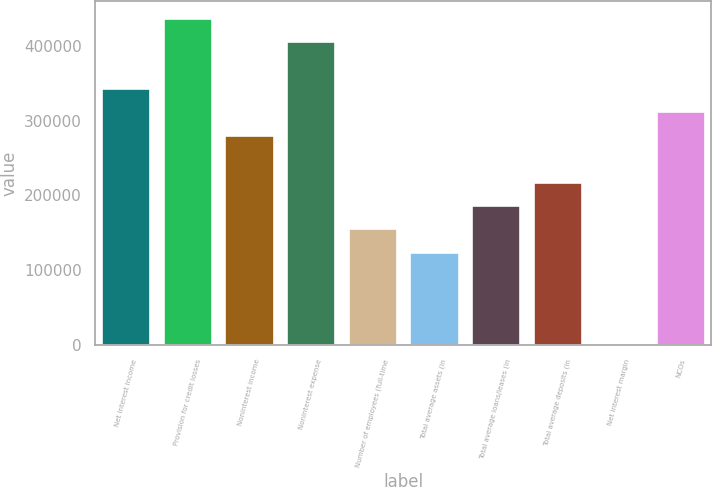Convert chart to OTSL. <chart><loc_0><loc_0><loc_500><loc_500><bar_chart><fcel>Net interest income<fcel>Provision for credit losses<fcel>Noninterest income<fcel>Noninterest expense<fcel>Number of employees (full-time<fcel>Total average assets (in<fcel>Total average loans/leases (in<fcel>Total average deposits (in<fcel>Net interest margin<fcel>NCOs<nl><fcel>343374<fcel>437021<fcel>280942<fcel>405805<fcel>156079<fcel>124863<fcel>187295<fcel>218511<fcel>0.07<fcel>312158<nl></chart> 